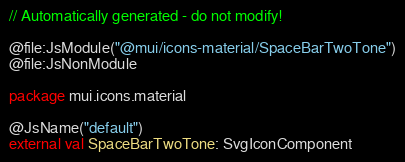Convert code to text. <code><loc_0><loc_0><loc_500><loc_500><_Kotlin_>// Automatically generated - do not modify!

@file:JsModule("@mui/icons-material/SpaceBarTwoTone")
@file:JsNonModule

package mui.icons.material

@JsName("default")
external val SpaceBarTwoTone: SvgIconComponent
</code> 